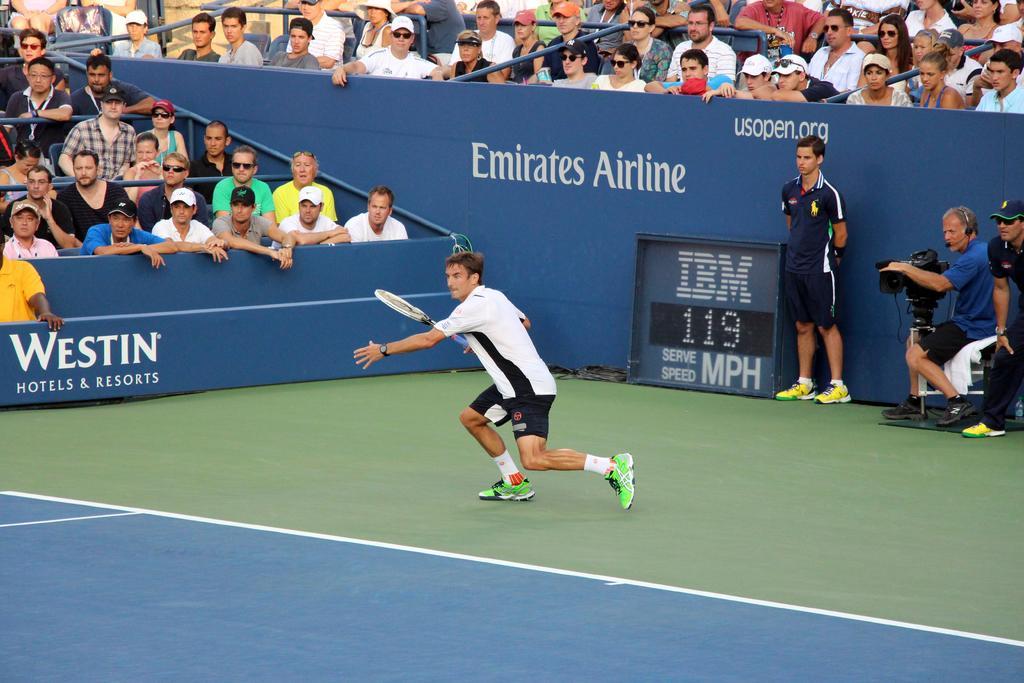Please provide a concise description of this image. In this image the person is holding a racket. At the backside there are group of people siting on the chair. On the right side the person is sitting and holding the camera. 